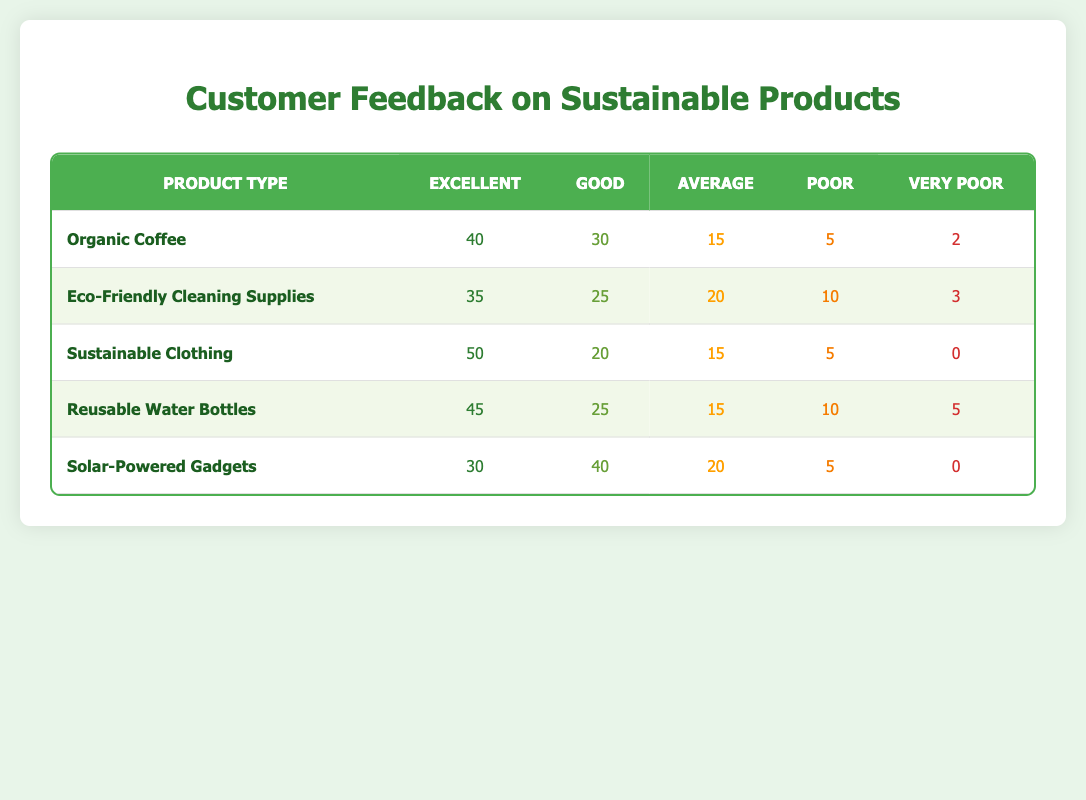What is the customer feedback rating for Reusable Water Bottles categorized as Excellent? The table shows that the rating of Reusable Water Bottles under the Excellent category is 45.
Answer: 45 Which product type received the highest rating for Excellent? By comparing the Excellent ratings across all product types, Sustainable Clothing has the highest rating of 50.
Answer: Sustainable Clothing What is the total number of poor ratings across all product types? Adding the Poor ratings for each product: 5 (Organic Coffee) + 10 (Eco-Friendly Cleaning Supplies) + 5 (Sustainable Clothing) + 10 (Reusable Water Bottles) + 5 (Solar-Powered Gadgets) gives a total of 35 poor ratings.
Answer: 35 Is the average rating for Eco-Friendly Cleaning Supplies higher than that of Solar-Powered Gadgets? For Eco-Friendly Cleaning Supplies: (35 * 1 + 25 * 2 + 20 * 3 + 10 * 4 + 3 * 5) / 93 = approximately 2.25. For Solar-Powered Gadgets: (30 * 1 + 40 * 2 + 20 * 3 + 5 * 4 + 0 * 5) / 95 = approximately 2.03. Therefore, Eco-Friendly Cleaning Supplies has a higher average rating.
Answer: Yes What percentage of customers rated Sustainable Clothing as Very Poor? For Sustainable Clothing, the Very Poor rating is 0 out of a total of 90 ratings (50 excellent + 20 good + 15 average + 5 poor + 0 very poor). Therefore, the percentage is (0/90) * 100 = 0%.
Answer: 0% How many more customers rated Organic Coffee as Good compared to Very Poor? The difference between the Good ratings and Very Poor ratings for Organic Coffee is 30 (Good) - 2 (Very Poor) = 28 customers.
Answer: 28 